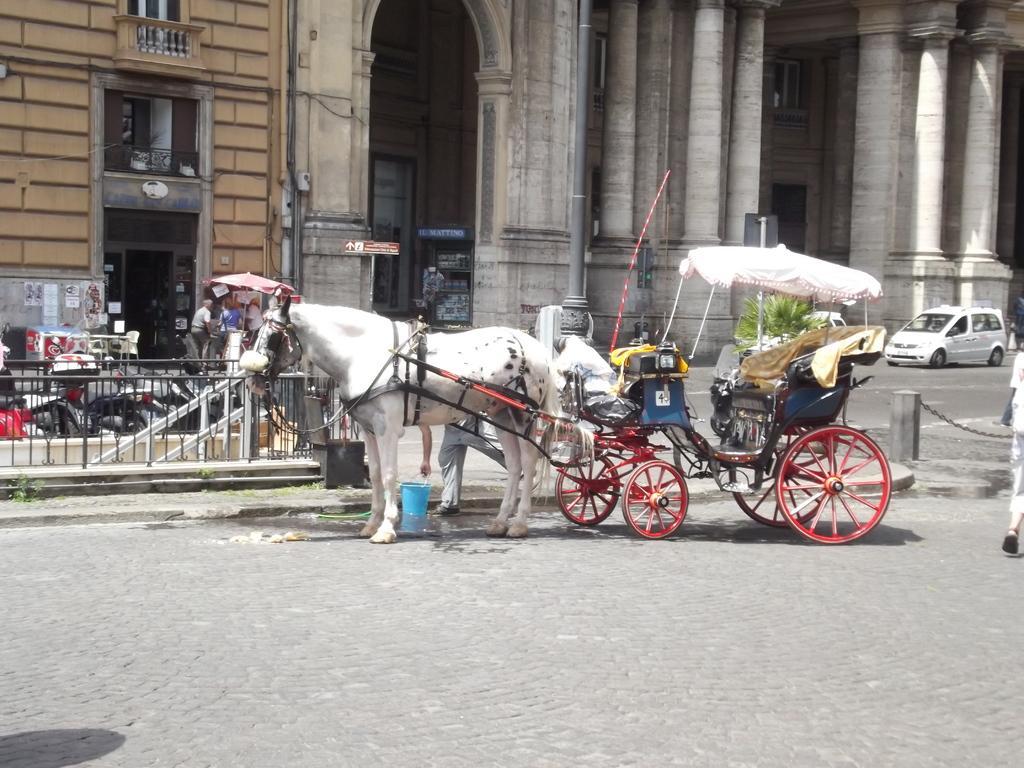In one or two sentences, can you explain what this image depicts? In the image there is a horse cart on the road and behind it there is a building with vehicles and people in front of it. 